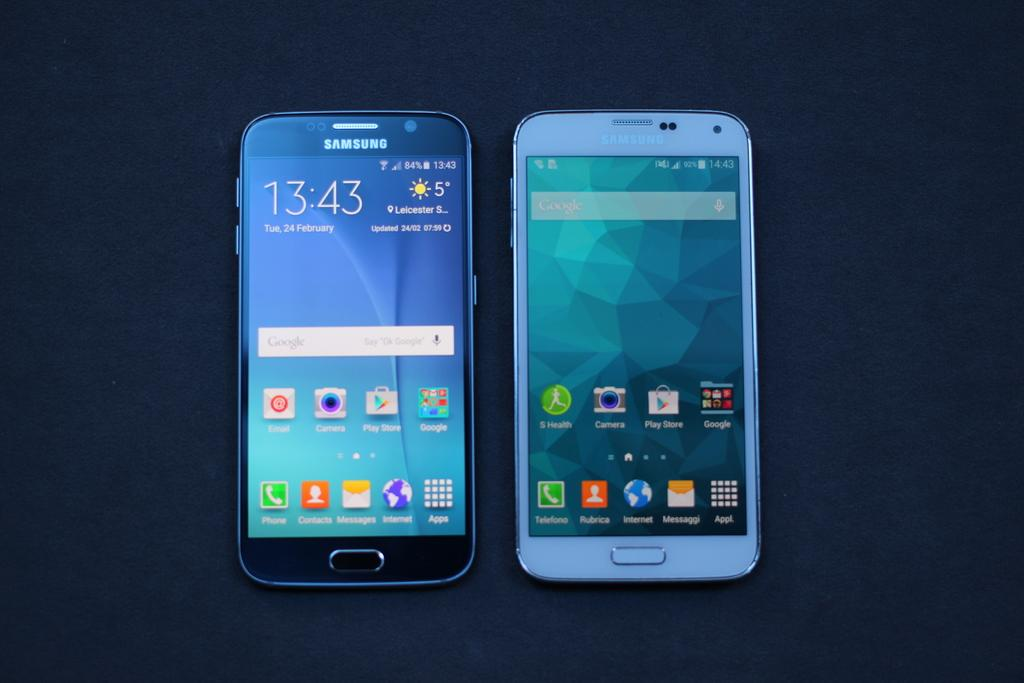<image>
Provide a brief description of the given image. two black and white SAMSUNG phones open to home screens 